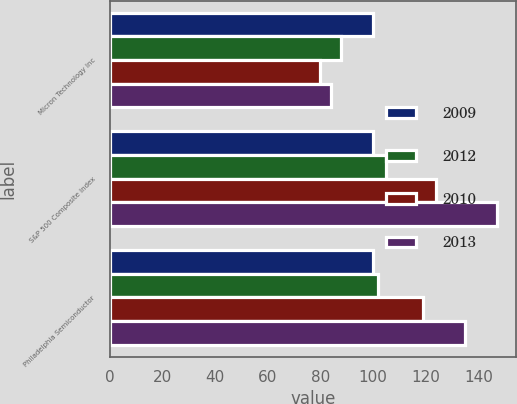Convert chart. <chart><loc_0><loc_0><loc_500><loc_500><stacked_bar_chart><ecel><fcel>Micron Technology Inc<fcel>S&P 500 Composite Index<fcel>Philadelphia Semiconductor<nl><fcel>2009<fcel>100<fcel>100<fcel>100<nl><fcel>2012<fcel>88<fcel>105<fcel>102<nl><fcel>2010<fcel>80<fcel>124<fcel>119<nl><fcel>2013<fcel>84<fcel>147<fcel>135<nl></chart> 